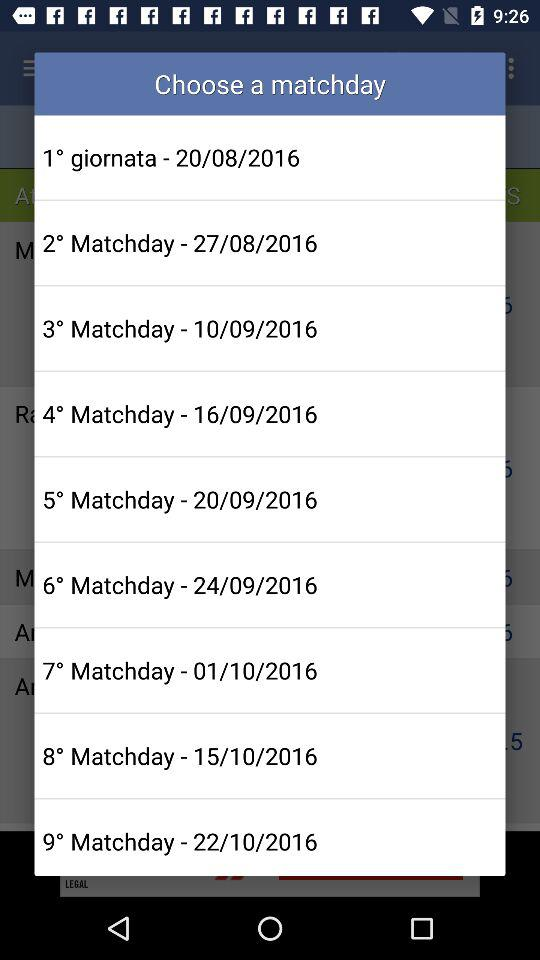What's the date of "2° Matchday"? The date is 27/08/2016. 